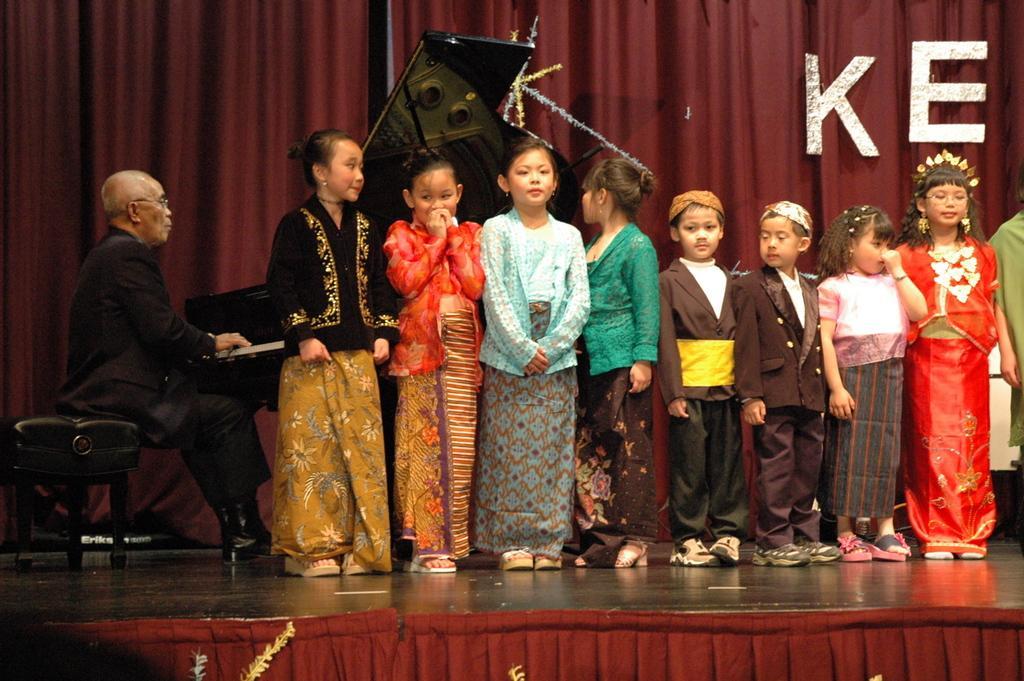Please provide a concise description of this image. In this image we can see a group of children standing on the stage. On the left side of the image we can see a person sitting on a chair and playing a piano. In the background, we can see curtains, some decorations and some text. 